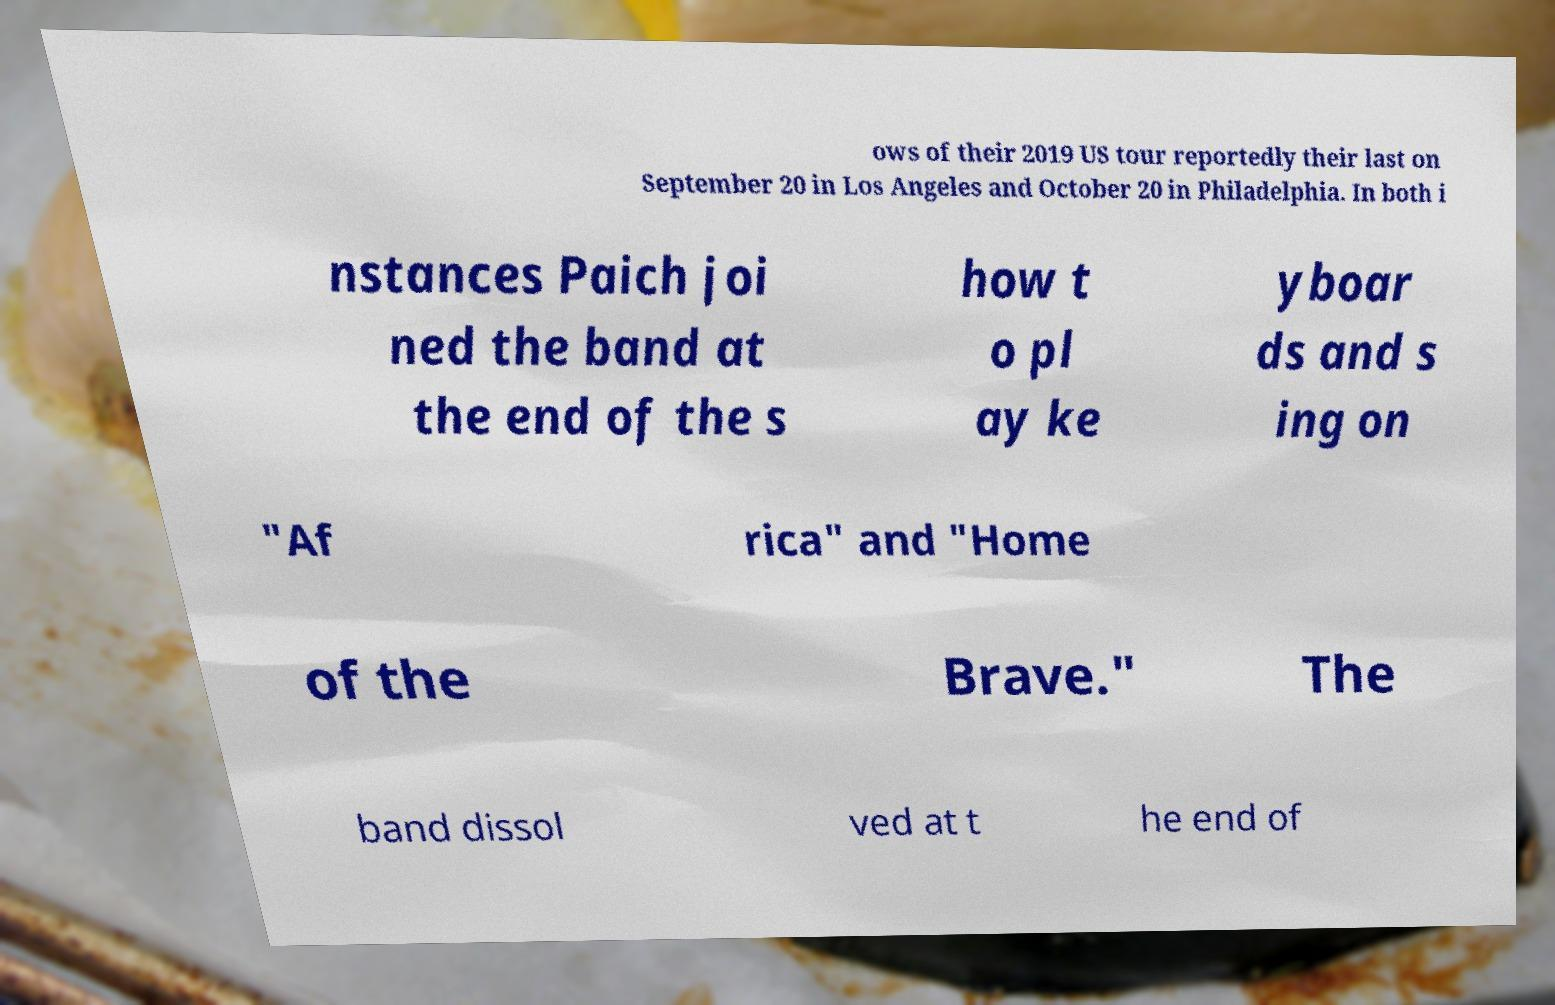Please read and relay the text visible in this image. What does it say? ows of their 2019 US tour reportedly their last on September 20 in Los Angeles and October 20 in Philadelphia. In both i nstances Paich joi ned the band at the end of the s how t o pl ay ke yboar ds and s ing on "Af rica" and "Home of the Brave." The band dissol ved at t he end of 